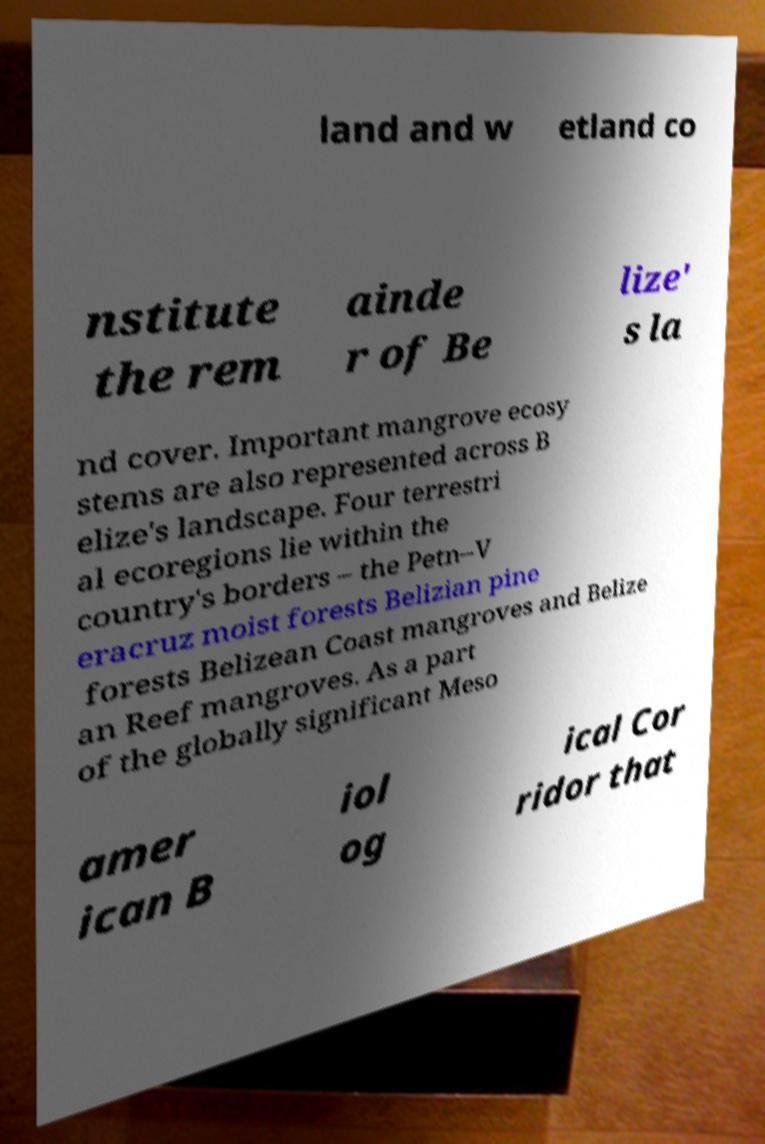Please read and relay the text visible in this image. What does it say? land and w etland co nstitute the rem ainde r of Be lize' s la nd cover. Important mangrove ecosy stems are also represented across B elize's landscape. Four terrestri al ecoregions lie within the country's borders – the Petn–V eracruz moist forests Belizian pine forests Belizean Coast mangroves and Belize an Reef mangroves. As a part of the globally significant Meso amer ican B iol og ical Cor ridor that 